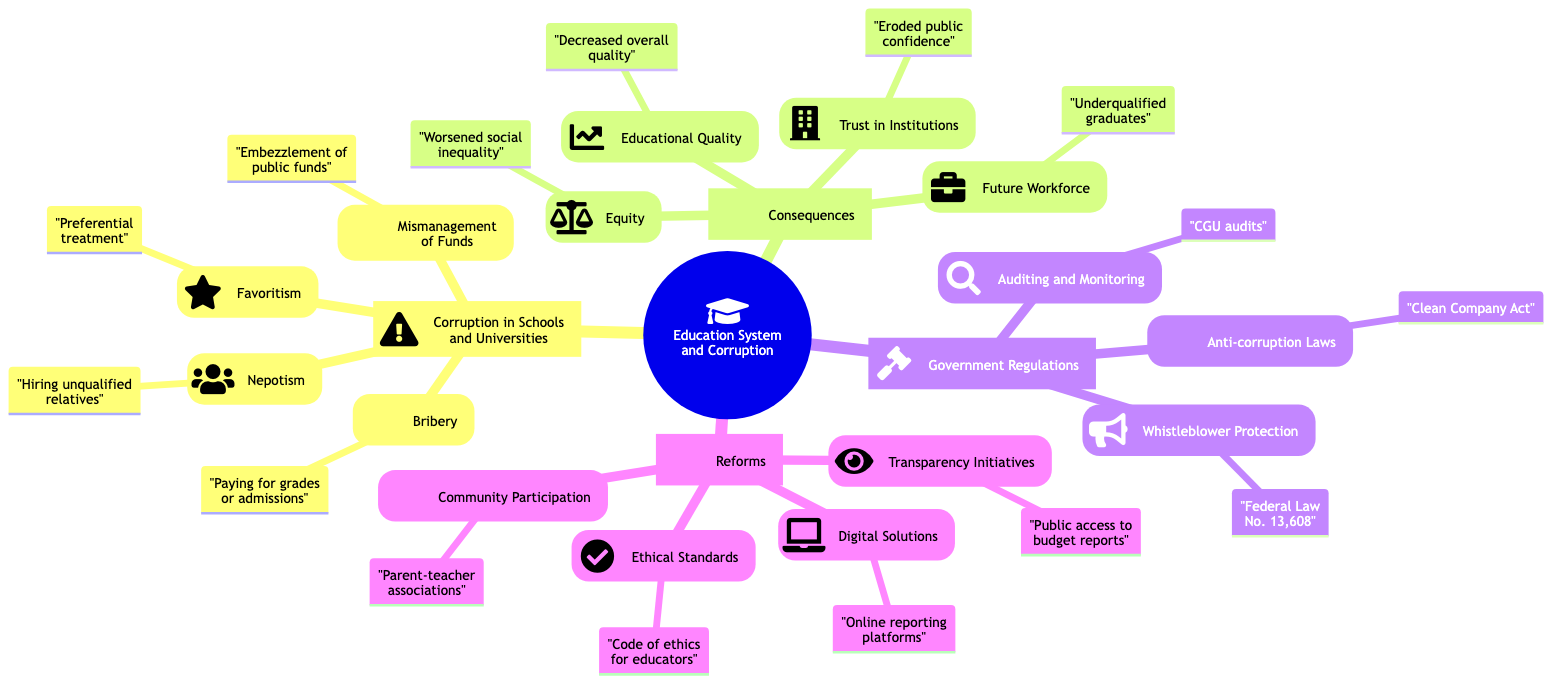What is one example of bribery in educational institutions? The diagram notes that one example of bribery is "Bribery in ENEM exam for university admissions." This is categorized under "Corruption in Schools and Universities" and specifically within the "Bribery" section.
Answer: Bribery in ENEM exam for university admissions How does nepotism affect educational positions? The section on "Nepotism" explains that it involves "Hiring unqualified relatives or friends for educational positions." This implies that nepotism leads to unqualified individuals occupying important educational roles, impacting educational quality.
Answer: Hiring unqualified relatives What are the consequences of decreased educational quality? The diagram indicates that one of the consequences is "Decreases the overall quality of education." This affects not only students' learning but also the future workforce, as unqualified recent graduates may enter the job market.
Answer: Decreases the overall quality of education What law does the diagram include under government regulations? The "Anti-corruption Laws" section mentions the "Clean Company Act." This act aims at preventing corruption specifically in educational institutions per the diagram's content.
Answer: Clean Company Act How does favoritism lead to social inequality? The "Equity" section notes that favoritism "Worsens social inequality by disadvantaging honest students," indicating that students who cannot afford bribes or have no connections may face unfair treatment, which deepens existing social divides.
Answer: Worsens social inequality by disadvantaging honest students Which reform aims to enhance transparency in education? Among the reforms listed, "Transparency Initiatives" specifically focus on this goal and emphasize "Making school and university operations more transparent" to foster accountability and trust.
Answer: Making school and university operations more transparent What impact does corruption have on trust in institutions? The diagram states that corruption "Erodes trust in educational and governmental institutions." The lack of integrity in how institutions operate diminishes the public's overall confidence in these organizations.
Answer: Erodes trust in educational and governmental institutions What is one way to involve the community in education management? The "Community Participation" reform suggests "Involving community in school management and decision making." This indicates that stakeholders such as parents can have a say in how schools are run, increasing accountability.
Answer: Involving community in school management and decision making 